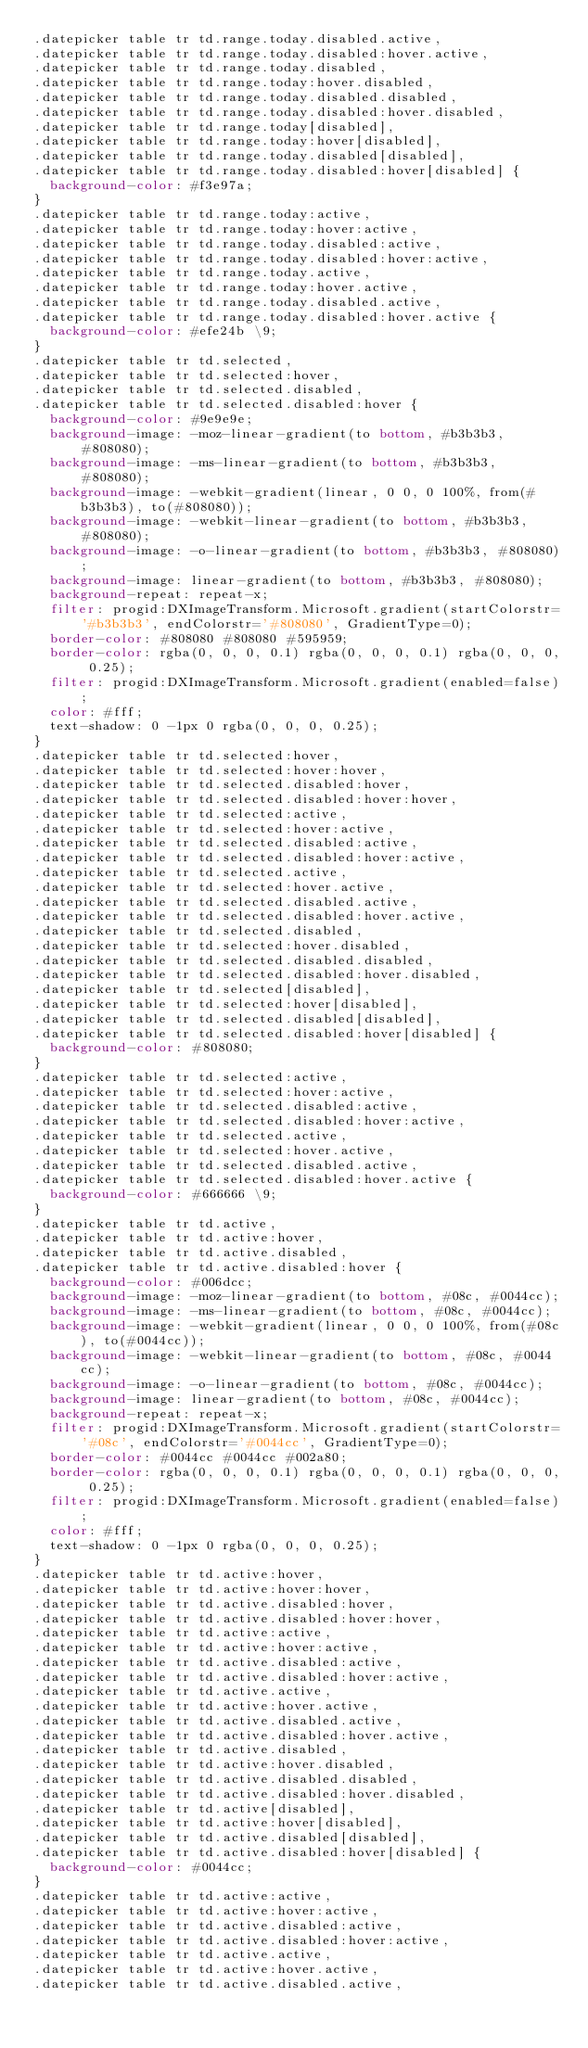Convert code to text. <code><loc_0><loc_0><loc_500><loc_500><_CSS_>.datepicker table tr td.range.today.disabled.active,
.datepicker table tr td.range.today.disabled:hover.active,
.datepicker table tr td.range.today.disabled,
.datepicker table tr td.range.today:hover.disabled,
.datepicker table tr td.range.today.disabled.disabled,
.datepicker table tr td.range.today.disabled:hover.disabled,
.datepicker table tr td.range.today[disabled],
.datepicker table tr td.range.today:hover[disabled],
.datepicker table tr td.range.today.disabled[disabled],
.datepicker table tr td.range.today.disabled:hover[disabled] {
  background-color: #f3e97a;
}
.datepicker table tr td.range.today:active,
.datepicker table tr td.range.today:hover:active,
.datepicker table tr td.range.today.disabled:active,
.datepicker table tr td.range.today.disabled:hover:active,
.datepicker table tr td.range.today.active,
.datepicker table tr td.range.today:hover.active,
.datepicker table tr td.range.today.disabled.active,
.datepicker table tr td.range.today.disabled:hover.active {
  background-color: #efe24b \9;
}
.datepicker table tr td.selected,
.datepicker table tr td.selected:hover,
.datepicker table tr td.selected.disabled,
.datepicker table tr td.selected.disabled:hover {
  background-color: #9e9e9e;
  background-image: -moz-linear-gradient(to bottom, #b3b3b3, #808080);
  background-image: -ms-linear-gradient(to bottom, #b3b3b3, #808080);
  background-image: -webkit-gradient(linear, 0 0, 0 100%, from(#b3b3b3), to(#808080));
  background-image: -webkit-linear-gradient(to bottom, #b3b3b3, #808080);
  background-image: -o-linear-gradient(to bottom, #b3b3b3, #808080);
  background-image: linear-gradient(to bottom, #b3b3b3, #808080);
  background-repeat: repeat-x;
  filter: progid:DXImageTransform.Microsoft.gradient(startColorstr='#b3b3b3', endColorstr='#808080', GradientType=0);
  border-color: #808080 #808080 #595959;
  border-color: rgba(0, 0, 0, 0.1) rgba(0, 0, 0, 0.1) rgba(0, 0, 0, 0.25);
  filter: progid:DXImageTransform.Microsoft.gradient(enabled=false);
  color: #fff;
  text-shadow: 0 -1px 0 rgba(0, 0, 0, 0.25);
}
.datepicker table tr td.selected:hover,
.datepicker table tr td.selected:hover:hover,
.datepicker table tr td.selected.disabled:hover,
.datepicker table tr td.selected.disabled:hover:hover,
.datepicker table tr td.selected:active,
.datepicker table tr td.selected:hover:active,
.datepicker table tr td.selected.disabled:active,
.datepicker table tr td.selected.disabled:hover:active,
.datepicker table tr td.selected.active,
.datepicker table tr td.selected:hover.active,
.datepicker table tr td.selected.disabled.active,
.datepicker table tr td.selected.disabled:hover.active,
.datepicker table tr td.selected.disabled,
.datepicker table tr td.selected:hover.disabled,
.datepicker table tr td.selected.disabled.disabled,
.datepicker table tr td.selected.disabled:hover.disabled,
.datepicker table tr td.selected[disabled],
.datepicker table tr td.selected:hover[disabled],
.datepicker table tr td.selected.disabled[disabled],
.datepicker table tr td.selected.disabled:hover[disabled] {
  background-color: #808080;
}
.datepicker table tr td.selected:active,
.datepicker table tr td.selected:hover:active,
.datepicker table tr td.selected.disabled:active,
.datepicker table tr td.selected.disabled:hover:active,
.datepicker table tr td.selected.active,
.datepicker table tr td.selected:hover.active,
.datepicker table tr td.selected.disabled.active,
.datepicker table tr td.selected.disabled:hover.active {
  background-color: #666666 \9;
}
.datepicker table tr td.active,
.datepicker table tr td.active:hover,
.datepicker table tr td.active.disabled,
.datepicker table tr td.active.disabled:hover {
  background-color: #006dcc;
  background-image: -moz-linear-gradient(to bottom, #08c, #0044cc);
  background-image: -ms-linear-gradient(to bottom, #08c, #0044cc);
  background-image: -webkit-gradient(linear, 0 0, 0 100%, from(#08c), to(#0044cc));
  background-image: -webkit-linear-gradient(to bottom, #08c, #0044cc);
  background-image: -o-linear-gradient(to bottom, #08c, #0044cc);
  background-image: linear-gradient(to bottom, #08c, #0044cc);
  background-repeat: repeat-x;
  filter: progid:DXImageTransform.Microsoft.gradient(startColorstr='#08c', endColorstr='#0044cc', GradientType=0);
  border-color: #0044cc #0044cc #002a80;
  border-color: rgba(0, 0, 0, 0.1) rgba(0, 0, 0, 0.1) rgba(0, 0, 0, 0.25);
  filter: progid:DXImageTransform.Microsoft.gradient(enabled=false);
  color: #fff;
  text-shadow: 0 -1px 0 rgba(0, 0, 0, 0.25);
}
.datepicker table tr td.active:hover,
.datepicker table tr td.active:hover:hover,
.datepicker table tr td.active.disabled:hover,
.datepicker table tr td.active.disabled:hover:hover,
.datepicker table tr td.active:active,
.datepicker table tr td.active:hover:active,
.datepicker table tr td.active.disabled:active,
.datepicker table tr td.active.disabled:hover:active,
.datepicker table tr td.active.active,
.datepicker table tr td.active:hover.active,
.datepicker table tr td.active.disabled.active,
.datepicker table tr td.active.disabled:hover.active,
.datepicker table tr td.active.disabled,
.datepicker table tr td.active:hover.disabled,
.datepicker table tr td.active.disabled.disabled,
.datepicker table tr td.active.disabled:hover.disabled,
.datepicker table tr td.active[disabled],
.datepicker table tr td.active:hover[disabled],
.datepicker table tr td.active.disabled[disabled],
.datepicker table tr td.active.disabled:hover[disabled] {
  background-color: #0044cc;
}
.datepicker table tr td.active:active,
.datepicker table tr td.active:hover:active,
.datepicker table tr td.active.disabled:active,
.datepicker table tr td.active.disabled:hover:active,
.datepicker table tr td.active.active,
.datepicker table tr td.active:hover.active,
.datepicker table tr td.active.disabled.active,</code> 